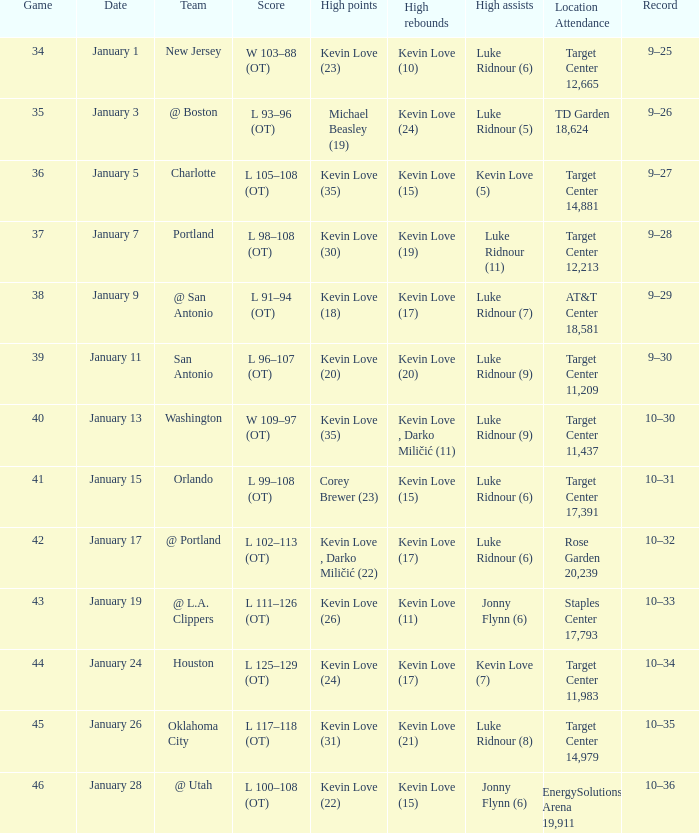What is the day for the 35th game? January 3. 